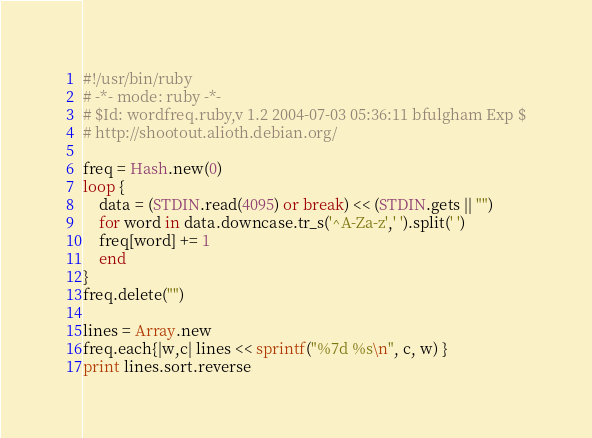Convert code to text. <code><loc_0><loc_0><loc_500><loc_500><_Ruby_>#!/usr/bin/ruby
# -*- mode: ruby -*-
# $Id: wordfreq.ruby,v 1.2 2004-07-03 05:36:11 bfulgham Exp $
# http://shootout.alioth.debian.org/

freq = Hash.new(0)
loop {
    data = (STDIN.read(4095) or break) << (STDIN.gets || "")
    for word in data.downcase.tr_s('^A-Za-z',' ').split(' ')
	freq[word] += 1
    end
}
freq.delete("")

lines = Array.new
freq.each{|w,c| lines << sprintf("%7d %s\n", c, w) }
print lines.sort.reverse
</code> 